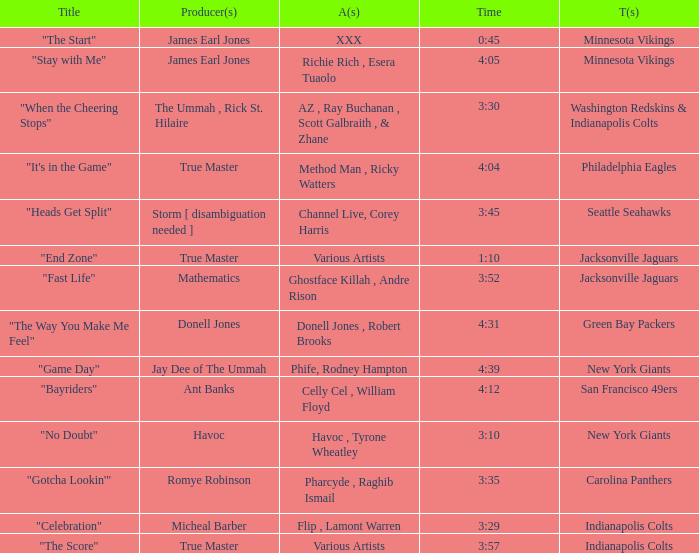Who is the artist of the New York Giants track "No Doubt"? Havoc , Tyrone Wheatley. 